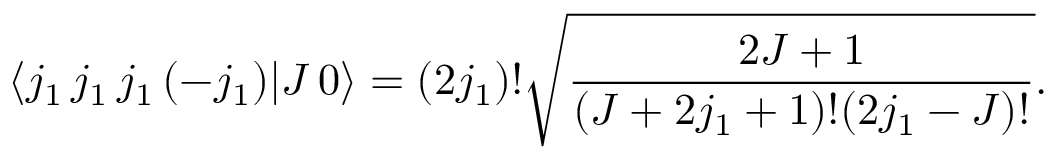Convert formula to latex. <formula><loc_0><loc_0><loc_500><loc_500>\langle j _ { 1 } \, j _ { 1 } \, j _ { 1 } \, ( - j _ { 1 } ) | J \, 0 \rangle = ( 2 j _ { 1 } ) ! { \sqrt { \frac { 2 J + 1 } { ( J + 2 j _ { 1 } + 1 ) ! ( 2 j _ { 1 } - J ) ! } } } .</formula> 